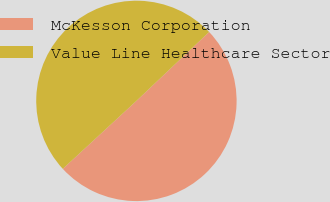<chart> <loc_0><loc_0><loc_500><loc_500><pie_chart><fcel>McKesson Corporation<fcel>Value Line Healthcare Sector<nl><fcel>50.21%<fcel>49.79%<nl></chart> 